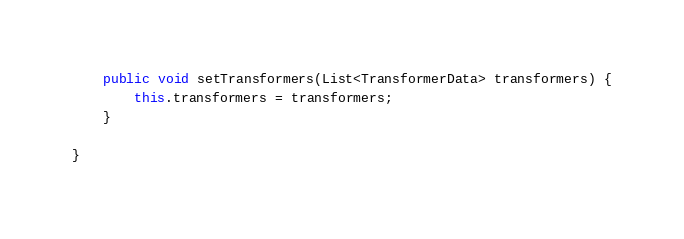<code> <loc_0><loc_0><loc_500><loc_500><_Java_>
    public void setTransformers(List<TransformerData> transformers) {
        this.transformers = transformers;
    }

}
</code> 